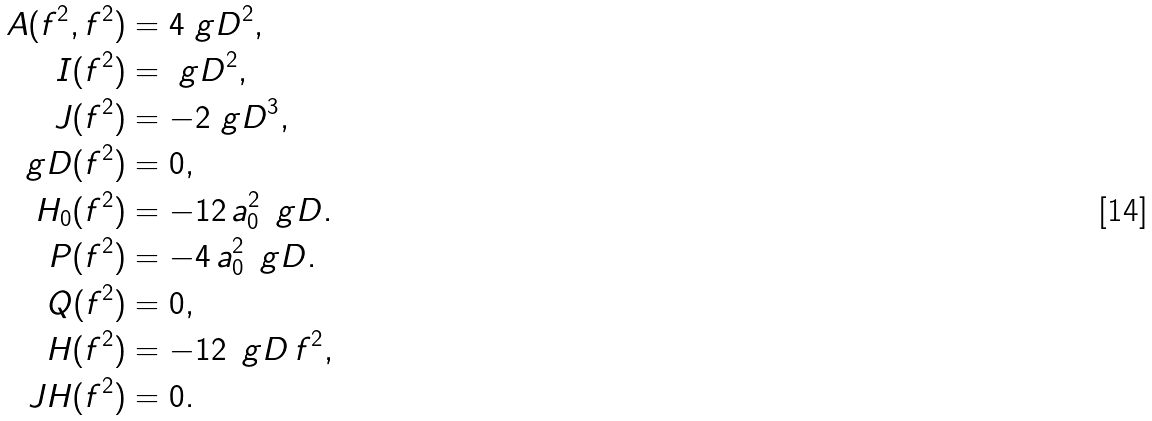<formula> <loc_0><loc_0><loc_500><loc_500>A ( f ^ { 2 } , f ^ { 2 } ) & = 4 \ g D ^ { 2 } , \\ I ( f ^ { 2 } ) & = \ g D ^ { 2 } , \\ J ( f ^ { 2 } ) & = - 2 \ g D ^ { 3 } , \\ \ g D ( f ^ { 2 } ) & = 0 , \\ H _ { 0 } ( f ^ { 2 } ) & = - 1 2 \, a _ { 0 } ^ { 2 } \, \ g D . \\ P ( f ^ { 2 } ) & = - 4 \, a _ { 0 } ^ { 2 } \, \ g D . \\ Q ( f ^ { 2 } ) & = 0 , \\ H ( f ^ { 2 } ) & = - 1 2 \, \ g D \, f ^ { 2 } , \\ \ J H ( f ^ { 2 } ) & = 0 .</formula> 